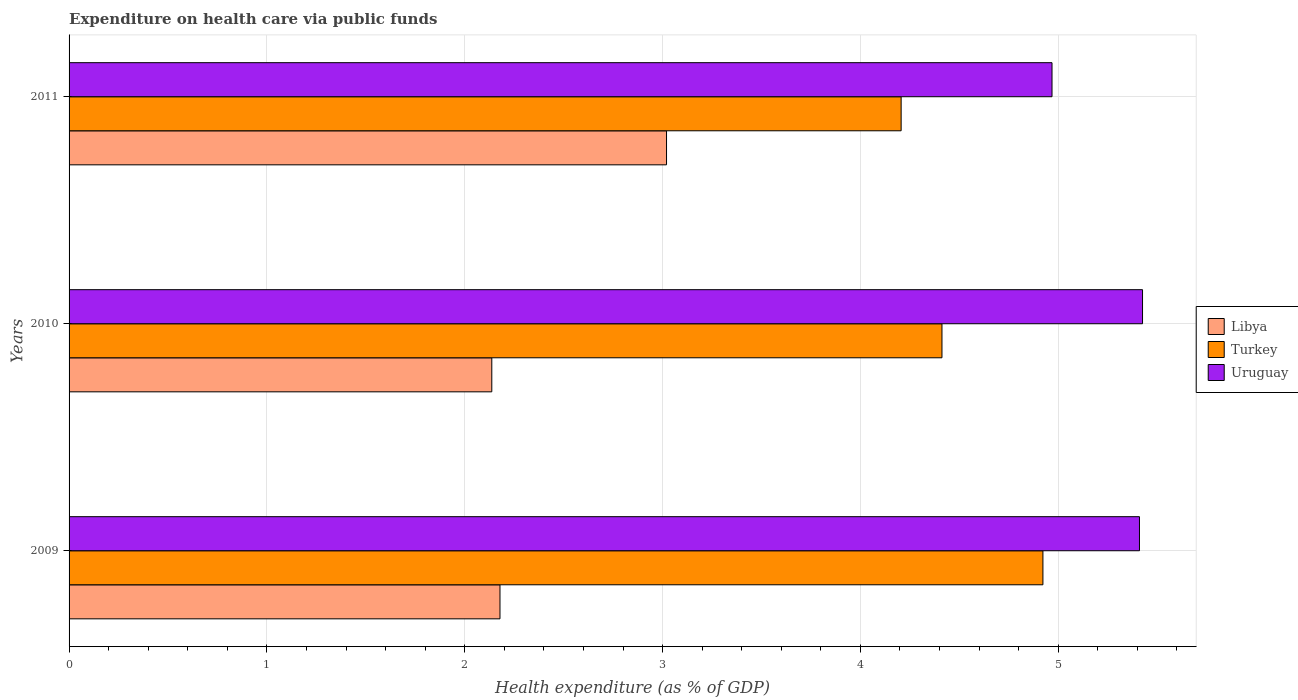How many different coloured bars are there?
Your answer should be compact. 3. Are the number of bars on each tick of the Y-axis equal?
Keep it short and to the point. Yes. How many bars are there on the 3rd tick from the bottom?
Ensure brevity in your answer.  3. What is the label of the 2nd group of bars from the top?
Make the answer very short. 2010. In how many cases, is the number of bars for a given year not equal to the number of legend labels?
Make the answer very short. 0. What is the expenditure made on health care in Uruguay in 2011?
Provide a short and direct response. 4.97. Across all years, what is the maximum expenditure made on health care in Uruguay?
Offer a terse response. 5.43. Across all years, what is the minimum expenditure made on health care in Libya?
Ensure brevity in your answer.  2.14. What is the total expenditure made on health care in Uruguay in the graph?
Provide a short and direct response. 15.81. What is the difference between the expenditure made on health care in Turkey in 2009 and that in 2010?
Your answer should be compact. 0.51. What is the difference between the expenditure made on health care in Turkey in 2009 and the expenditure made on health care in Libya in 2011?
Your answer should be compact. 1.9. What is the average expenditure made on health care in Turkey per year?
Offer a terse response. 4.51. In the year 2010, what is the difference between the expenditure made on health care in Turkey and expenditure made on health care in Uruguay?
Offer a terse response. -1.01. What is the ratio of the expenditure made on health care in Turkey in 2009 to that in 2011?
Make the answer very short. 1.17. Is the expenditure made on health care in Uruguay in 2009 less than that in 2011?
Your answer should be very brief. No. What is the difference between the highest and the second highest expenditure made on health care in Libya?
Make the answer very short. 0.84. What is the difference between the highest and the lowest expenditure made on health care in Uruguay?
Ensure brevity in your answer.  0.46. In how many years, is the expenditure made on health care in Uruguay greater than the average expenditure made on health care in Uruguay taken over all years?
Your answer should be very brief. 2. What does the 3rd bar from the top in 2010 represents?
Offer a very short reply. Libya. What does the 2nd bar from the bottom in 2011 represents?
Provide a succinct answer. Turkey. How many bars are there?
Offer a very short reply. 9. Are all the bars in the graph horizontal?
Your answer should be very brief. Yes. What is the difference between two consecutive major ticks on the X-axis?
Your response must be concise. 1. Are the values on the major ticks of X-axis written in scientific E-notation?
Provide a short and direct response. No. Does the graph contain any zero values?
Your answer should be compact. No. Does the graph contain grids?
Your response must be concise. Yes. Where does the legend appear in the graph?
Your answer should be compact. Center right. What is the title of the graph?
Your response must be concise. Expenditure on health care via public funds. What is the label or title of the X-axis?
Provide a succinct answer. Health expenditure (as % of GDP). What is the Health expenditure (as % of GDP) of Libya in 2009?
Your answer should be compact. 2.18. What is the Health expenditure (as % of GDP) in Turkey in 2009?
Make the answer very short. 4.92. What is the Health expenditure (as % of GDP) in Uruguay in 2009?
Give a very brief answer. 5.41. What is the Health expenditure (as % of GDP) in Libya in 2010?
Keep it short and to the point. 2.14. What is the Health expenditure (as % of GDP) in Turkey in 2010?
Your answer should be very brief. 4.41. What is the Health expenditure (as % of GDP) of Uruguay in 2010?
Provide a short and direct response. 5.43. What is the Health expenditure (as % of GDP) in Libya in 2011?
Make the answer very short. 3.02. What is the Health expenditure (as % of GDP) of Turkey in 2011?
Ensure brevity in your answer.  4.21. What is the Health expenditure (as % of GDP) of Uruguay in 2011?
Provide a succinct answer. 4.97. Across all years, what is the maximum Health expenditure (as % of GDP) of Libya?
Your answer should be compact. 3.02. Across all years, what is the maximum Health expenditure (as % of GDP) of Turkey?
Make the answer very short. 4.92. Across all years, what is the maximum Health expenditure (as % of GDP) in Uruguay?
Offer a very short reply. 5.43. Across all years, what is the minimum Health expenditure (as % of GDP) of Libya?
Make the answer very short. 2.14. Across all years, what is the minimum Health expenditure (as % of GDP) of Turkey?
Offer a terse response. 4.21. Across all years, what is the minimum Health expenditure (as % of GDP) in Uruguay?
Give a very brief answer. 4.97. What is the total Health expenditure (as % of GDP) of Libya in the graph?
Your answer should be compact. 7.33. What is the total Health expenditure (as % of GDP) of Turkey in the graph?
Ensure brevity in your answer.  13.54. What is the total Health expenditure (as % of GDP) in Uruguay in the graph?
Ensure brevity in your answer.  15.81. What is the difference between the Health expenditure (as % of GDP) of Libya in 2009 and that in 2010?
Keep it short and to the point. 0.04. What is the difference between the Health expenditure (as % of GDP) in Turkey in 2009 and that in 2010?
Keep it short and to the point. 0.51. What is the difference between the Health expenditure (as % of GDP) in Uruguay in 2009 and that in 2010?
Offer a terse response. -0.02. What is the difference between the Health expenditure (as % of GDP) in Libya in 2009 and that in 2011?
Your answer should be compact. -0.84. What is the difference between the Health expenditure (as % of GDP) in Turkey in 2009 and that in 2011?
Provide a short and direct response. 0.72. What is the difference between the Health expenditure (as % of GDP) in Uruguay in 2009 and that in 2011?
Your answer should be very brief. 0.44. What is the difference between the Health expenditure (as % of GDP) in Libya in 2010 and that in 2011?
Make the answer very short. -0.88. What is the difference between the Health expenditure (as % of GDP) of Turkey in 2010 and that in 2011?
Make the answer very short. 0.21. What is the difference between the Health expenditure (as % of GDP) in Uruguay in 2010 and that in 2011?
Provide a succinct answer. 0.46. What is the difference between the Health expenditure (as % of GDP) in Libya in 2009 and the Health expenditure (as % of GDP) in Turkey in 2010?
Your answer should be very brief. -2.23. What is the difference between the Health expenditure (as % of GDP) of Libya in 2009 and the Health expenditure (as % of GDP) of Uruguay in 2010?
Your response must be concise. -3.25. What is the difference between the Health expenditure (as % of GDP) in Turkey in 2009 and the Health expenditure (as % of GDP) in Uruguay in 2010?
Offer a very short reply. -0.5. What is the difference between the Health expenditure (as % of GDP) in Libya in 2009 and the Health expenditure (as % of GDP) in Turkey in 2011?
Offer a terse response. -2.03. What is the difference between the Health expenditure (as % of GDP) of Libya in 2009 and the Health expenditure (as % of GDP) of Uruguay in 2011?
Your response must be concise. -2.79. What is the difference between the Health expenditure (as % of GDP) of Turkey in 2009 and the Health expenditure (as % of GDP) of Uruguay in 2011?
Your answer should be compact. -0.05. What is the difference between the Health expenditure (as % of GDP) in Libya in 2010 and the Health expenditure (as % of GDP) in Turkey in 2011?
Offer a very short reply. -2.07. What is the difference between the Health expenditure (as % of GDP) in Libya in 2010 and the Health expenditure (as % of GDP) in Uruguay in 2011?
Provide a succinct answer. -2.83. What is the difference between the Health expenditure (as % of GDP) of Turkey in 2010 and the Health expenditure (as % of GDP) of Uruguay in 2011?
Your response must be concise. -0.56. What is the average Health expenditure (as % of GDP) of Libya per year?
Give a very brief answer. 2.44. What is the average Health expenditure (as % of GDP) in Turkey per year?
Offer a very short reply. 4.51. What is the average Health expenditure (as % of GDP) of Uruguay per year?
Offer a very short reply. 5.27. In the year 2009, what is the difference between the Health expenditure (as % of GDP) of Libya and Health expenditure (as % of GDP) of Turkey?
Make the answer very short. -2.74. In the year 2009, what is the difference between the Health expenditure (as % of GDP) of Libya and Health expenditure (as % of GDP) of Uruguay?
Your answer should be very brief. -3.23. In the year 2009, what is the difference between the Health expenditure (as % of GDP) of Turkey and Health expenditure (as % of GDP) of Uruguay?
Keep it short and to the point. -0.49. In the year 2010, what is the difference between the Health expenditure (as % of GDP) of Libya and Health expenditure (as % of GDP) of Turkey?
Your response must be concise. -2.28. In the year 2010, what is the difference between the Health expenditure (as % of GDP) of Libya and Health expenditure (as % of GDP) of Uruguay?
Provide a succinct answer. -3.29. In the year 2010, what is the difference between the Health expenditure (as % of GDP) in Turkey and Health expenditure (as % of GDP) in Uruguay?
Provide a short and direct response. -1.01. In the year 2011, what is the difference between the Health expenditure (as % of GDP) of Libya and Health expenditure (as % of GDP) of Turkey?
Provide a succinct answer. -1.19. In the year 2011, what is the difference between the Health expenditure (as % of GDP) in Libya and Health expenditure (as % of GDP) in Uruguay?
Ensure brevity in your answer.  -1.95. In the year 2011, what is the difference between the Health expenditure (as % of GDP) of Turkey and Health expenditure (as % of GDP) of Uruguay?
Provide a succinct answer. -0.76. What is the ratio of the Health expenditure (as % of GDP) of Libya in 2009 to that in 2010?
Your answer should be compact. 1.02. What is the ratio of the Health expenditure (as % of GDP) in Turkey in 2009 to that in 2010?
Give a very brief answer. 1.12. What is the ratio of the Health expenditure (as % of GDP) of Libya in 2009 to that in 2011?
Your answer should be very brief. 0.72. What is the ratio of the Health expenditure (as % of GDP) of Turkey in 2009 to that in 2011?
Your response must be concise. 1.17. What is the ratio of the Health expenditure (as % of GDP) in Uruguay in 2009 to that in 2011?
Make the answer very short. 1.09. What is the ratio of the Health expenditure (as % of GDP) in Libya in 2010 to that in 2011?
Make the answer very short. 0.71. What is the ratio of the Health expenditure (as % of GDP) in Turkey in 2010 to that in 2011?
Provide a short and direct response. 1.05. What is the ratio of the Health expenditure (as % of GDP) of Uruguay in 2010 to that in 2011?
Your response must be concise. 1.09. What is the difference between the highest and the second highest Health expenditure (as % of GDP) of Libya?
Make the answer very short. 0.84. What is the difference between the highest and the second highest Health expenditure (as % of GDP) in Turkey?
Keep it short and to the point. 0.51. What is the difference between the highest and the second highest Health expenditure (as % of GDP) in Uruguay?
Your answer should be very brief. 0.02. What is the difference between the highest and the lowest Health expenditure (as % of GDP) in Libya?
Offer a terse response. 0.88. What is the difference between the highest and the lowest Health expenditure (as % of GDP) of Turkey?
Provide a short and direct response. 0.72. What is the difference between the highest and the lowest Health expenditure (as % of GDP) in Uruguay?
Your answer should be compact. 0.46. 